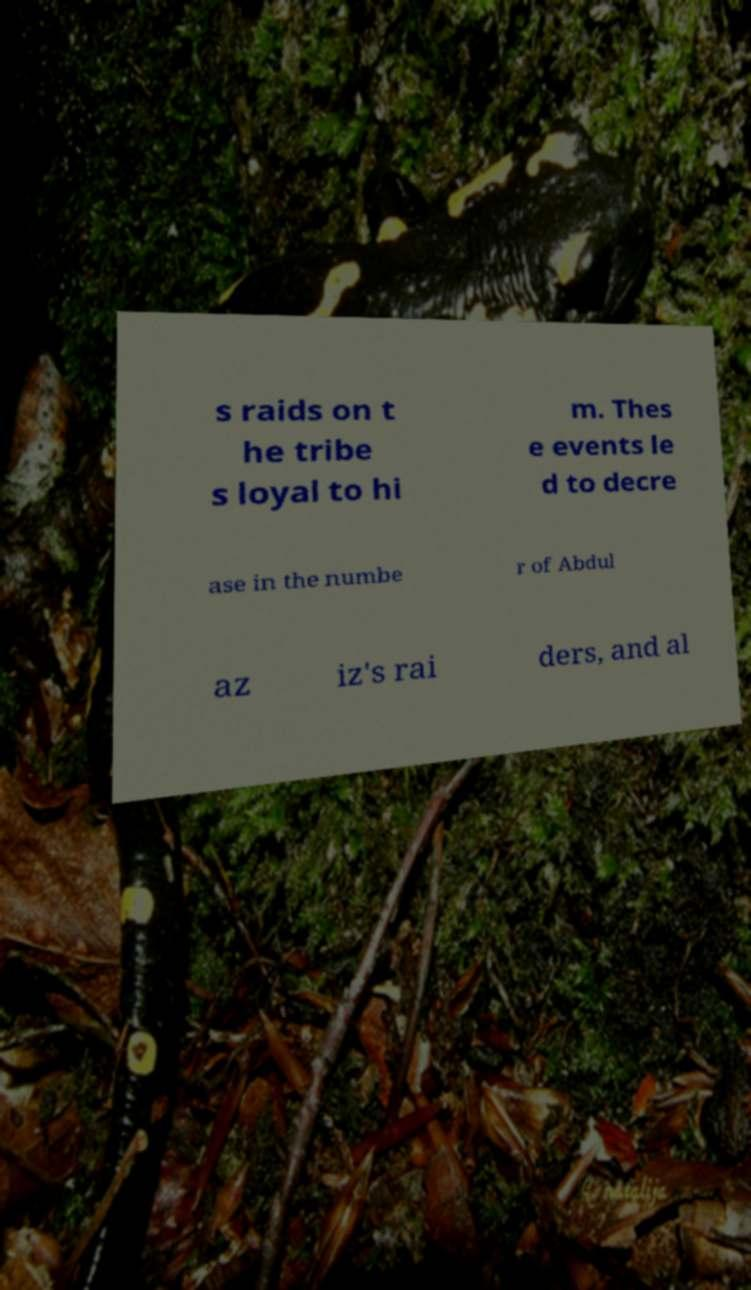I need the written content from this picture converted into text. Can you do that? s raids on t he tribe s loyal to hi m. Thes e events le d to decre ase in the numbe r of Abdul az iz's rai ders, and al 